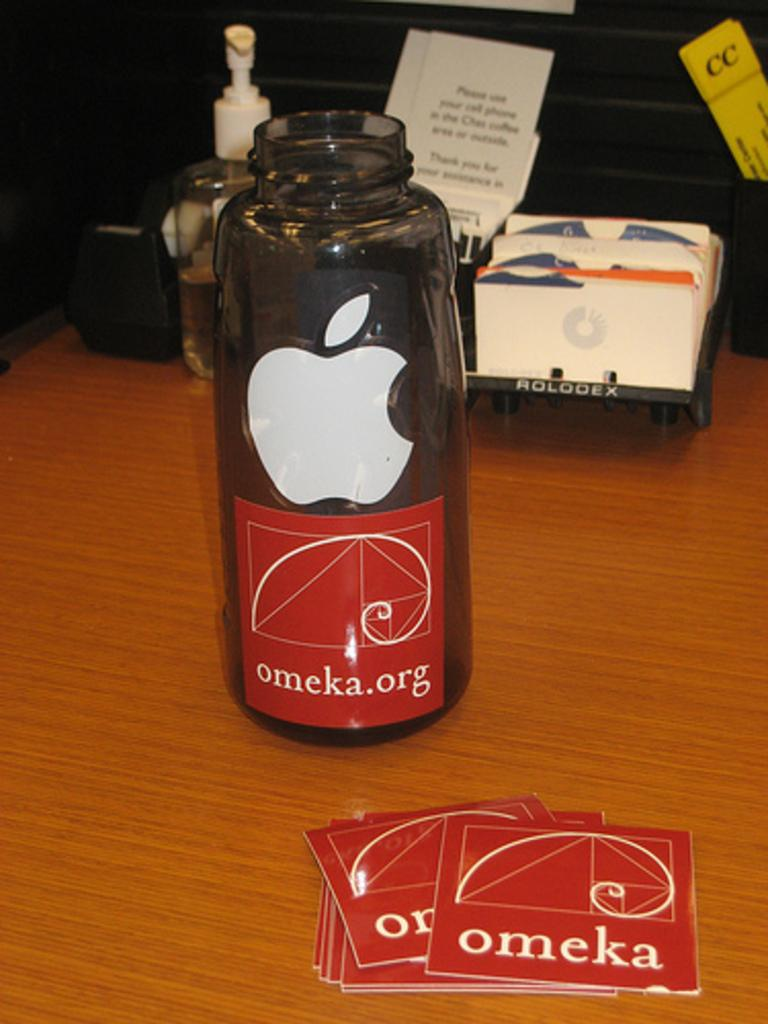<image>
Describe the image concisely. A water bottle with the Apple logo on it has a sticker saying omeka.org. 